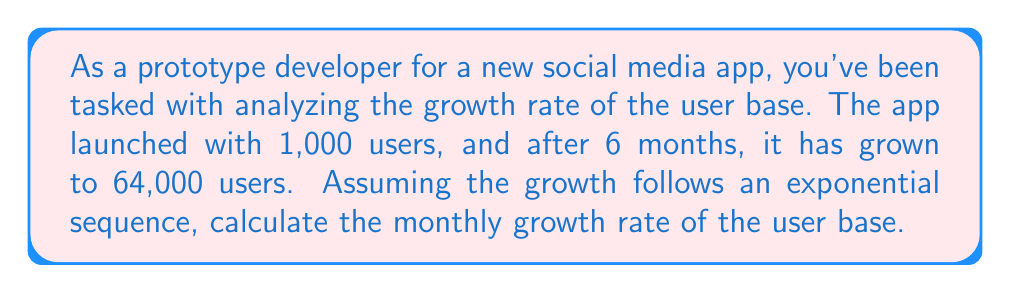Teach me how to tackle this problem. Let's approach this step-by-step:

1) The general form of an exponential sequence is:

   $$A_n = A_0 \cdot r^n$$

   Where $A_n$ is the value after $n$ periods, $A_0$ is the initial value, and $r$ is the growth rate.

2) In this case:
   $A_0 = 1,000$ (initial users)
   $A_6 = 64,000$ (users after 6 months)
   $n = 6$ (number of months)

3) Plugging these into the formula:

   $$64,000 = 1,000 \cdot r^6$$

4) Divide both sides by 1,000:

   $$64 = r^6$$

5) Take the 6th root of both sides:

   $$\sqrt[6]{64} = r$$

6) Calculate:

   $$r \approx 1.8$$

7) To express this as a percentage growth rate, subtract 1 and multiply by 100:

   $$(1.8 - 1) \times 100 = 80\%$$

Thus, the monthly growth rate is approximately 80%.
Answer: 80% 